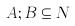Convert formula to latex. <formula><loc_0><loc_0><loc_500><loc_500>A ; B \subseteq N</formula> 